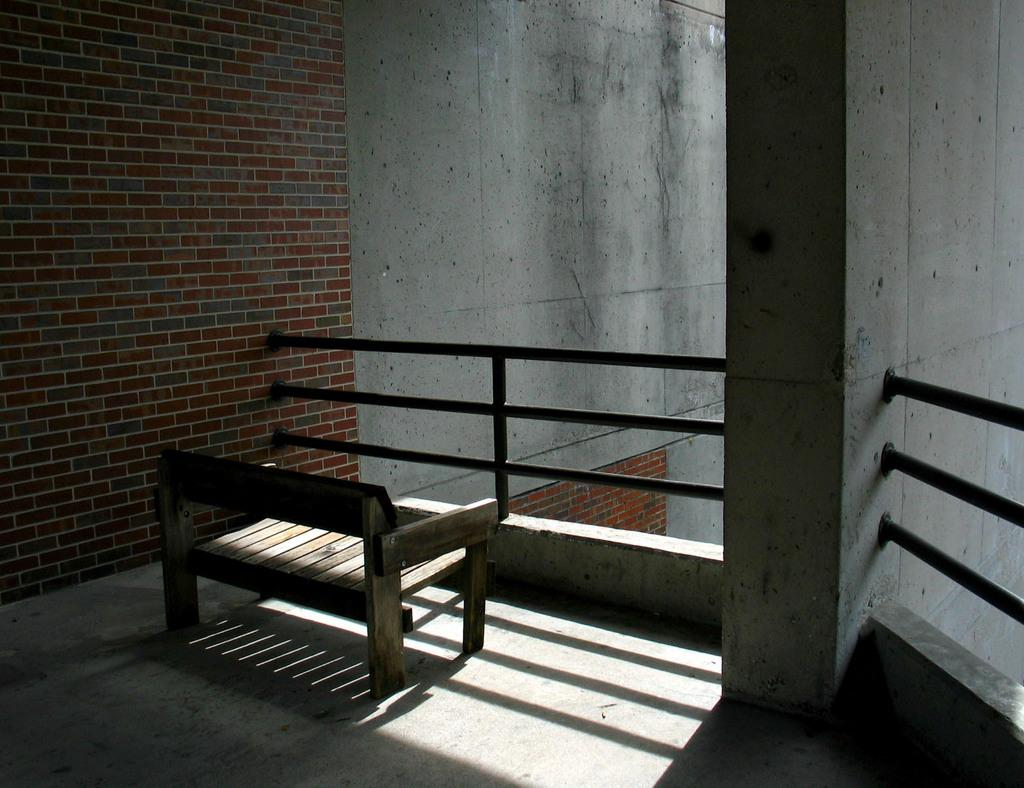What type of structure can be seen in the image? There are walls in the image, which suggests a building or enclosed space. What can be seen attached to the walls in the image? There is railing in the image, which might be used for support or safety. What type of furniture is present in the image? There is a bench on the floor in the image, which could be used for sitting or resting. What type of cheese is being played on the instrument in the image? There is no cheese or instrument present in the image. 